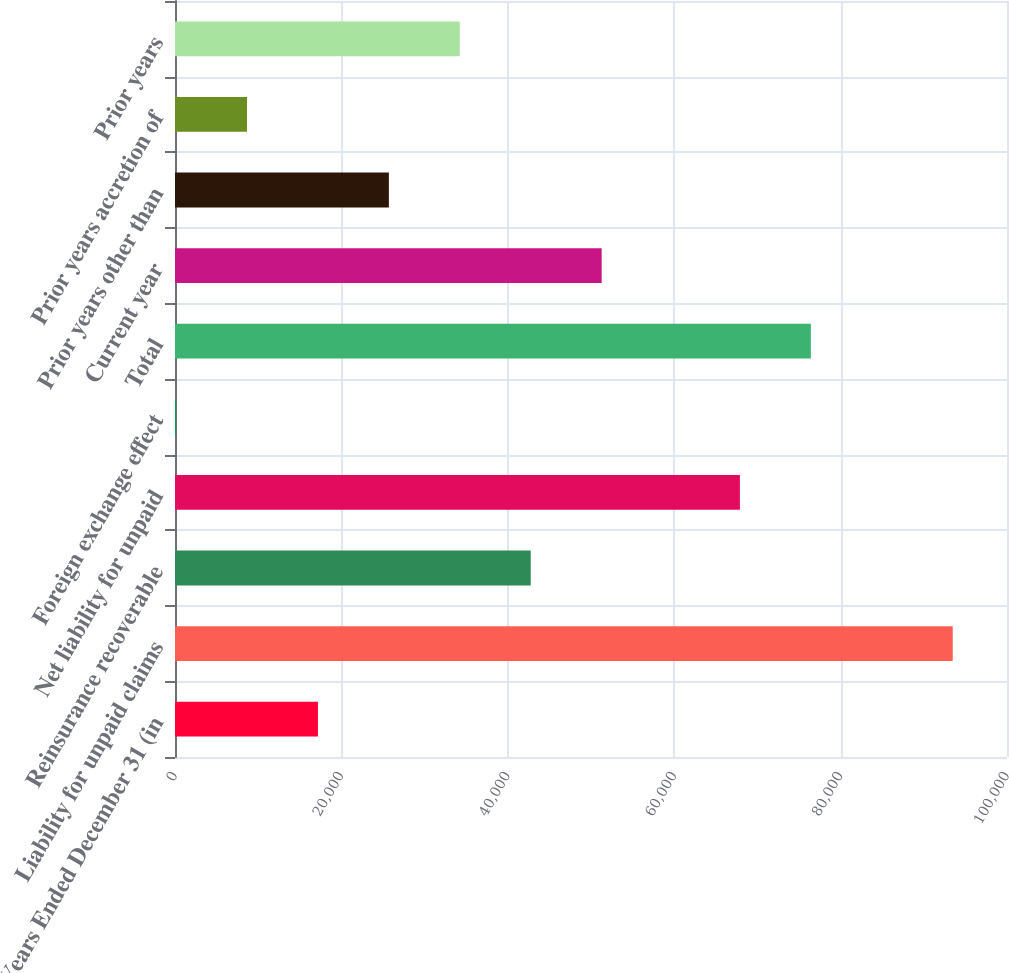<chart> <loc_0><loc_0><loc_500><loc_500><bar_chart><fcel>Years Ended December 31 (in<fcel>Liability for unpaid claims<fcel>Reinsurance recoverable<fcel>Net liability for unpaid<fcel>Foreign exchange effect<fcel>Total<fcel>Current year<fcel>Prior years other than<fcel>Prior years accretion of<fcel>Prior years<nl><fcel>17178<fcel>93477<fcel>42756<fcel>67899<fcel>126<fcel>76425<fcel>51282<fcel>25704<fcel>8652<fcel>34230<nl></chart> 